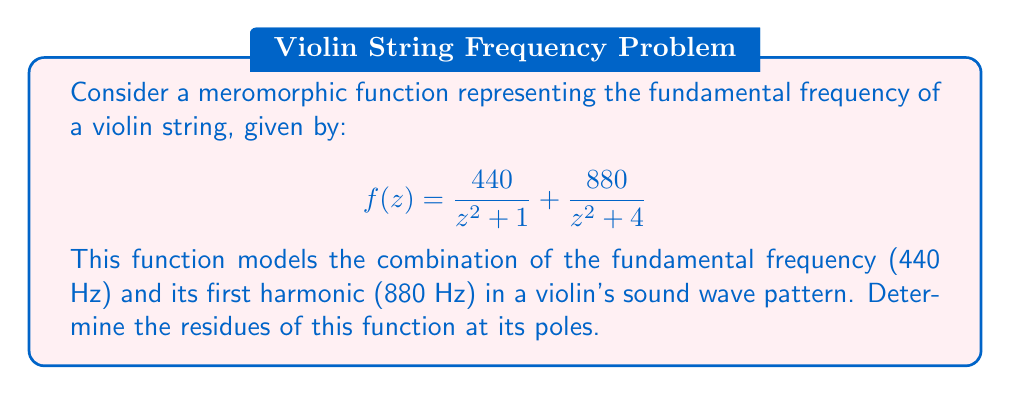Help me with this question. Let's approach this step-by-step:

1) First, we need to identify the poles of the function. The poles occur where the denominator of each term is zero:
   
   For $\frac{440}{z^2 + 1}$, the poles are at $z = \pm i$
   For $\frac{880}{z^2 + 4}$, the poles are at $z = \pm 2i$

2) Now, let's calculate the residues at each pole:

   a) For $z = i$ (pole of order 1):
      $$\text{Res}(f, i) = \lim_{z \to i} (z-i) \cdot \frac{440}{z^2 + 1} = \lim_{z \to i} \frac{440(z-i)}{(z+i)(z-i)} = \frac{440}{2i} = -220i$$

   b) For $z = -i$ (pole of order 1):
      $$\text{Res}(f, -i) = \lim_{z \to -i} (z+i) \cdot \frac{440}{z^2 + 1} = \lim_{z \to -i} \frac{440(z+i)}{(z-i)(z+i)} = \frac{440}{-2i} = 220i$$

   c) For $z = 2i$ (pole of order 1):
      $$\text{Res}(f, 2i) = \lim_{z \to 2i} (z-2i) \cdot \frac{880}{z^2 + 4} = \lim_{z \to 2i} \frac{880(z-2i)}{(z+2i)(z-2i)} = \frac{880}{4i} = -220i$$

   d) For $z = -2i$ (pole of order 1):
      $$\text{Res}(f, -2i) = \lim_{z \to -2i} (z+2i) \cdot \frac{880}{z^2 + 4} = \lim_{z \to -2i} \frac{880(z+2i)}{(z-2i)(z+2i)} = \frac{880}{-4i} = 220i$$

3) Therefore, the residues at the poles $i$, $-i$, $2i$, and $-2i$ are $-220i$, $220i$, $-220i$, and $220i$ respectively.
Answer: $\text{Res}(f, i) = -220i$, $\text{Res}(f, -i) = 220i$, $\text{Res}(f, 2i) = -220i$, $\text{Res}(f, -2i) = 220i$ 